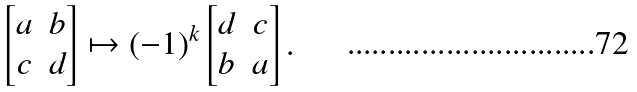<formula> <loc_0><loc_0><loc_500><loc_500>\begin{bmatrix} a & b \\ c & d \end{bmatrix} \mapsto ( - 1 ) ^ { k } \begin{bmatrix} d & c \\ b & a \end{bmatrix} .</formula> 